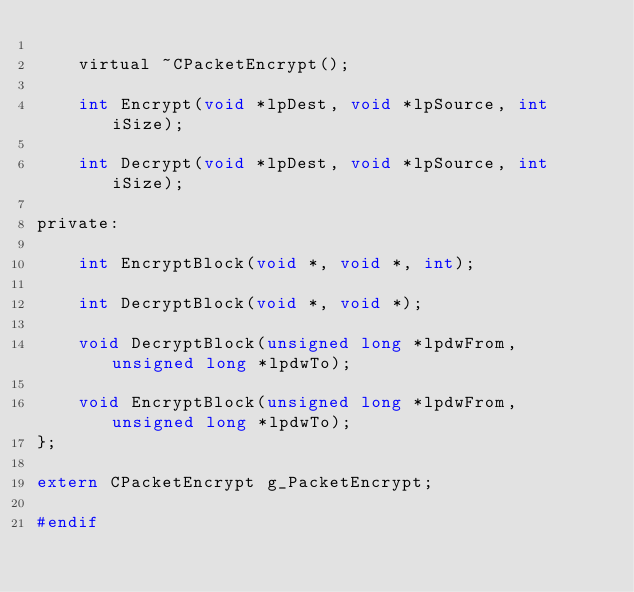Convert code to text. <code><loc_0><loc_0><loc_500><loc_500><_C_>
    virtual ~CPacketEncrypt();

    int Encrypt(void *lpDest, void *lpSource, int iSize);

    int Decrypt(void *lpDest, void *lpSource, int iSize);

private:

    int EncryptBlock(void *, void *, int);

    int DecryptBlock(void *, void *);

    void DecryptBlock(unsigned long *lpdwFrom, unsigned long *lpdwTo);

    void EncryptBlock(unsigned long *lpdwFrom, unsigned long *lpdwTo);
};

extern CPacketEncrypt g_PacketEncrypt;

#endif</code> 